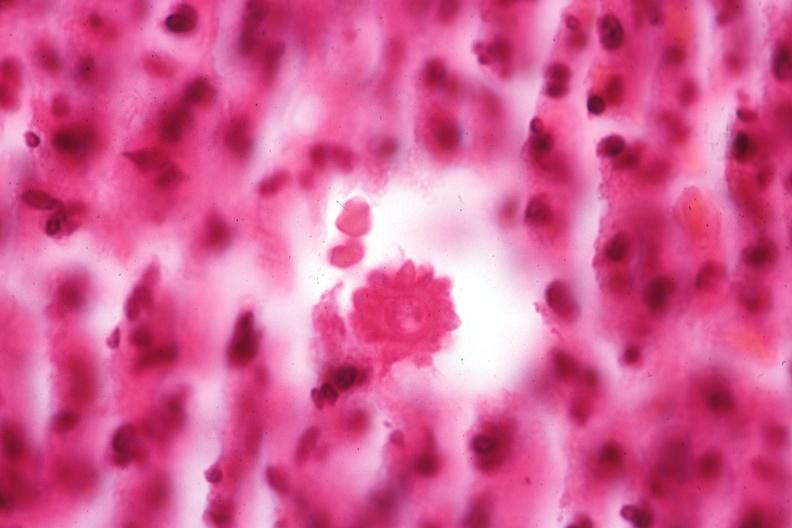s sporotrichosis present?
Answer the question using a single word or phrase. Yes 